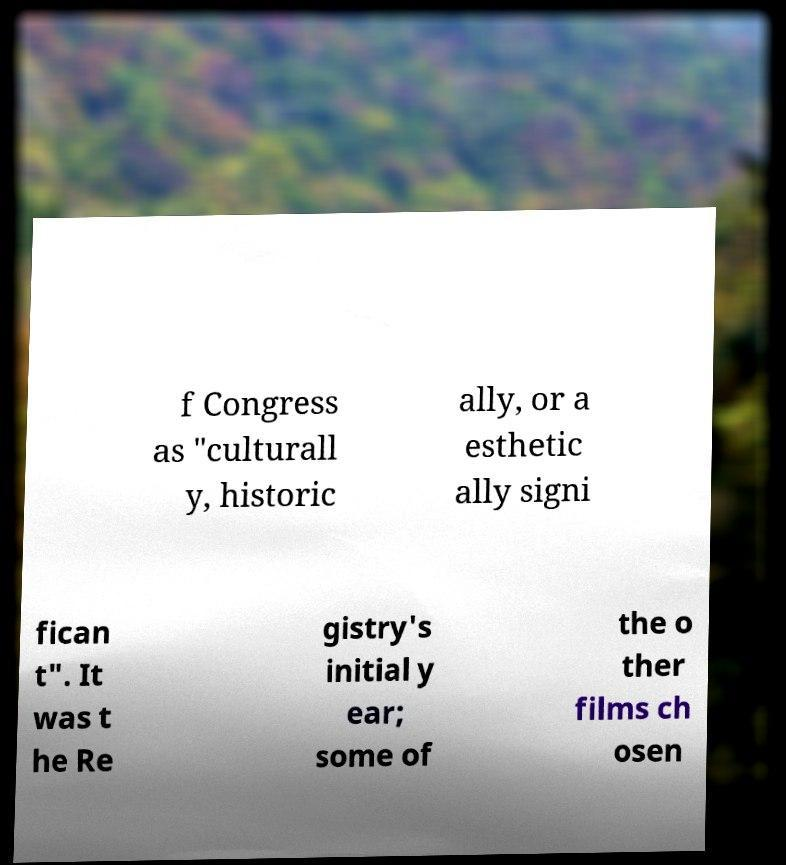Can you read and provide the text displayed in the image?This photo seems to have some interesting text. Can you extract and type it out for me? f Congress as "culturall y, historic ally, or a esthetic ally signi fican t". It was t he Re gistry's initial y ear; some of the o ther films ch osen 